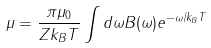<formula> <loc_0><loc_0><loc_500><loc_500>\mu = \frac { \pi \mu _ { 0 } } { Z k _ { B } T } \int d \omega B ( \omega ) e ^ { - \omega / k _ { B } T }</formula> 